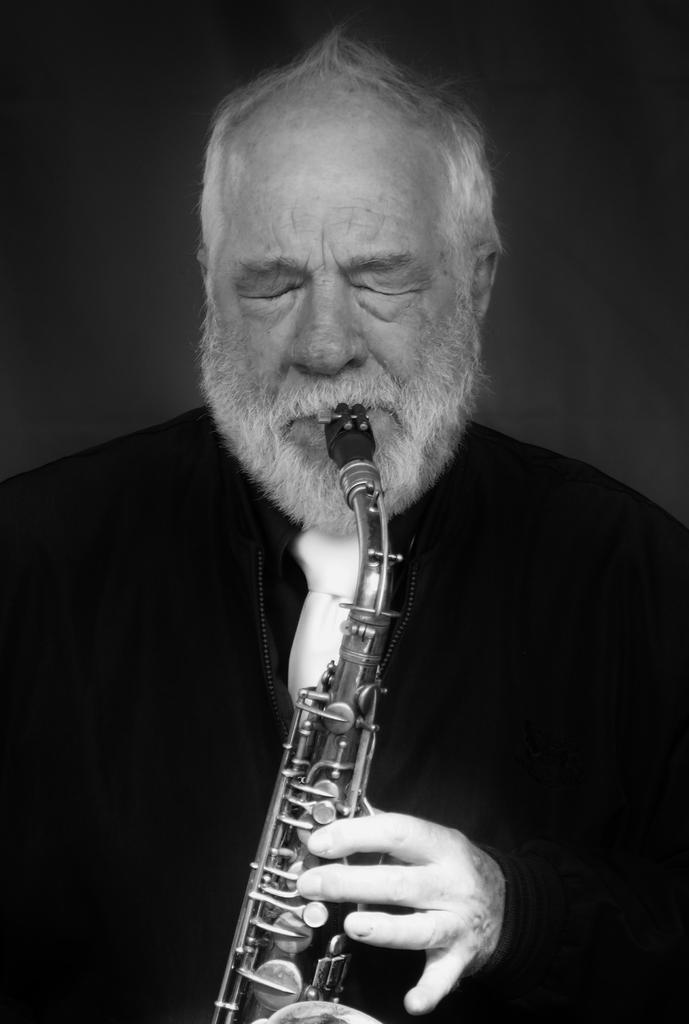Who is the main subject in the image? There is an old man in the image. What is the old man wearing? The old man is wearing a black suit. What is the old man doing in the image? The old man is playing a trumpet. What type of office equipment can be seen in the image? There is no office equipment present in the image; it features an old man playing a trumpet. What kind of error is the old man making in the image? There is no error being made by the old man in the image; he is simply playing a trumpet. 